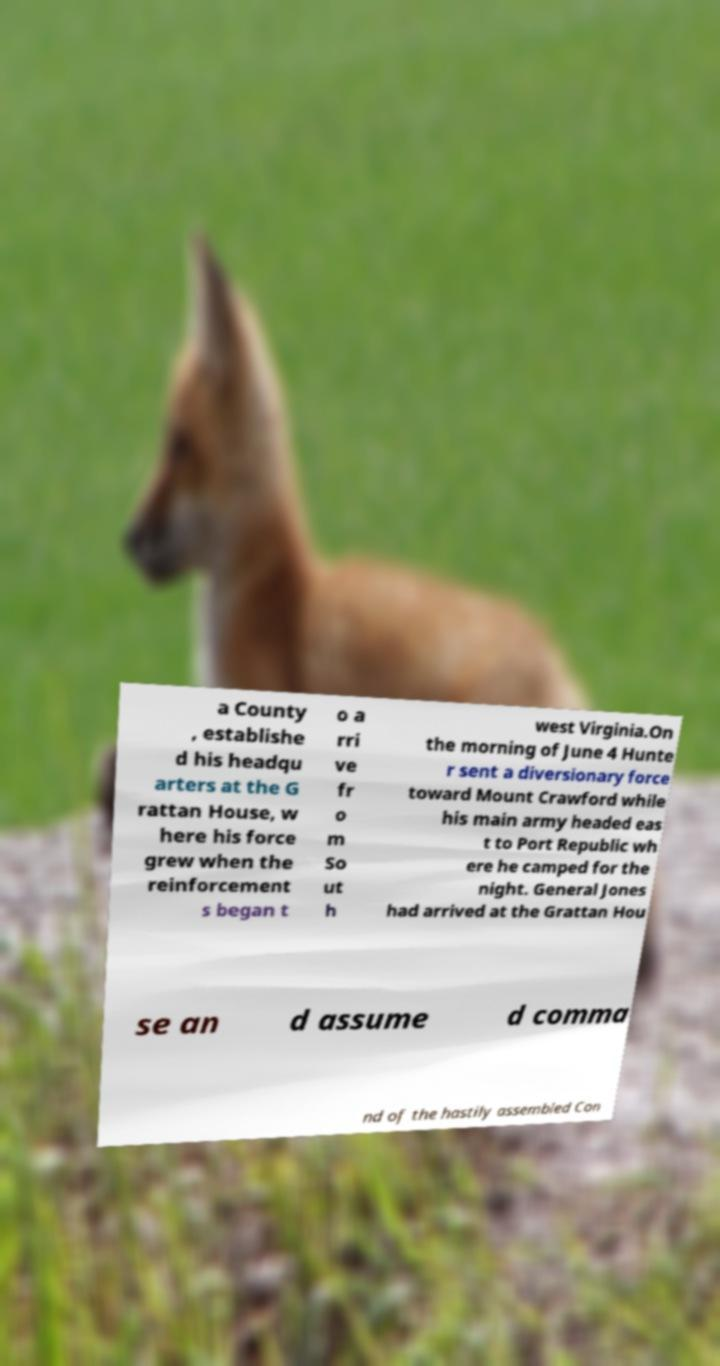Could you extract and type out the text from this image? a County , establishe d his headqu arters at the G rattan House, w here his force grew when the reinforcement s began t o a rri ve fr o m So ut h west Virginia.On the morning of June 4 Hunte r sent a diversionary force toward Mount Crawford while his main army headed eas t to Port Republic wh ere he camped for the night. General Jones had arrived at the Grattan Hou se an d assume d comma nd of the hastily assembled Con 